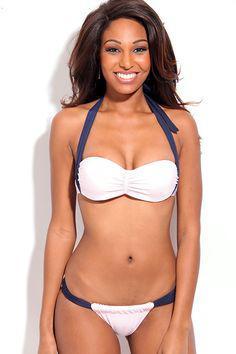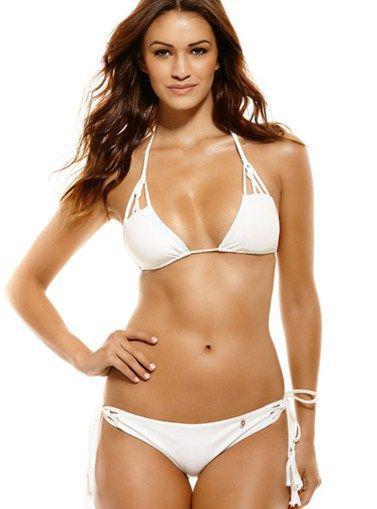The first image is the image on the left, the second image is the image on the right. For the images displayed, is the sentence "Each model is wearing a black bikini top and bottom." factually correct? Answer yes or no. No. The first image is the image on the left, the second image is the image on the right. Given the left and right images, does the statement "Both bottoms are solid black." hold true? Answer yes or no. No. 